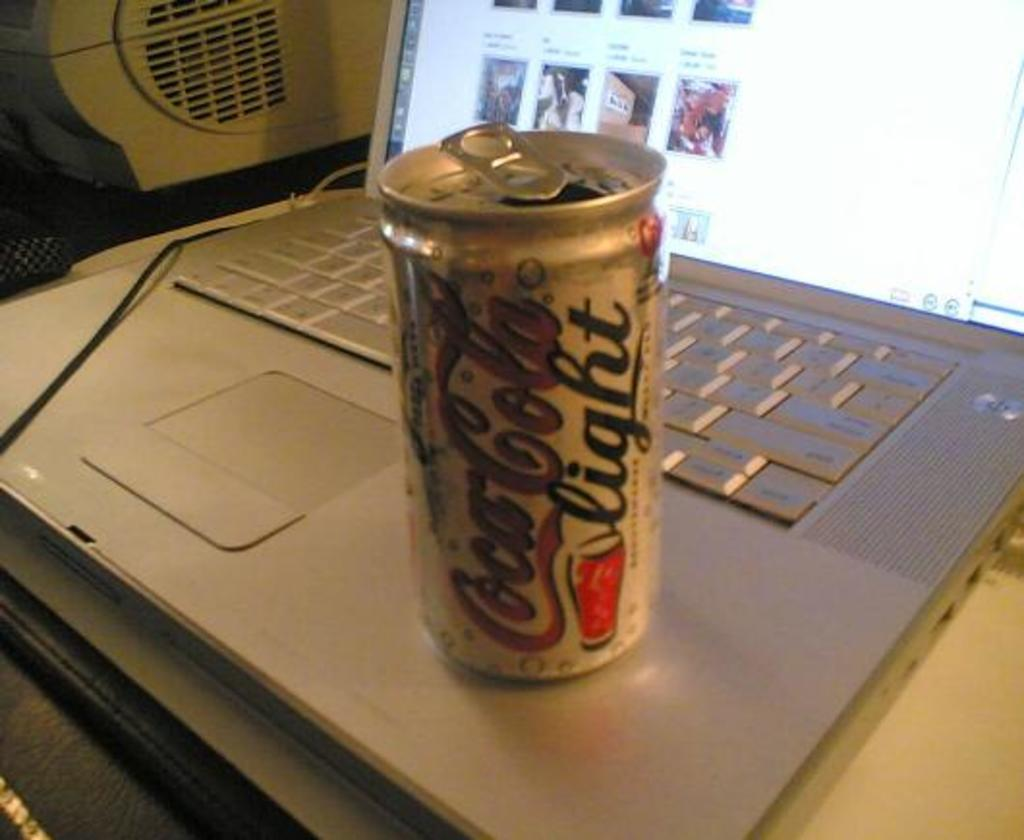<image>
Provide a brief description of the given image. A can of Coca-Cola light sits on top of an open laptop. 